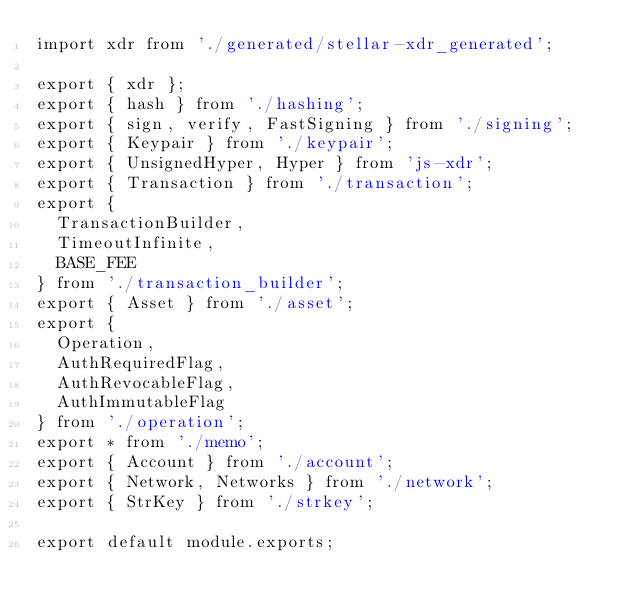Convert code to text. <code><loc_0><loc_0><loc_500><loc_500><_JavaScript_>import xdr from './generated/stellar-xdr_generated';

export { xdr };
export { hash } from './hashing';
export { sign, verify, FastSigning } from './signing';
export { Keypair } from './keypair';
export { UnsignedHyper, Hyper } from 'js-xdr';
export { Transaction } from './transaction';
export {
  TransactionBuilder,
  TimeoutInfinite,
  BASE_FEE
} from './transaction_builder';
export { Asset } from './asset';
export {
  Operation,
  AuthRequiredFlag,
  AuthRevocableFlag,
  AuthImmutableFlag
} from './operation';
export * from './memo';
export { Account } from './account';
export { Network, Networks } from './network';
export { StrKey } from './strkey';

export default module.exports;
</code> 